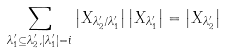Convert formula to latex. <formula><loc_0><loc_0><loc_500><loc_500>\sum _ { \lambda _ { 1 } ^ { \prime } \subseteq \lambda _ { 2 } ^ { \prime } , | \lambda _ { 1 } ^ { \prime } | = i } \left | X _ { \lambda _ { 2 } ^ { \prime } / \lambda _ { 1 } ^ { \prime } } \right | \left | X _ { \lambda _ { 1 } ^ { \prime } } \right | = \left | X _ { \lambda _ { 2 } ^ { \prime } } \right |</formula> 